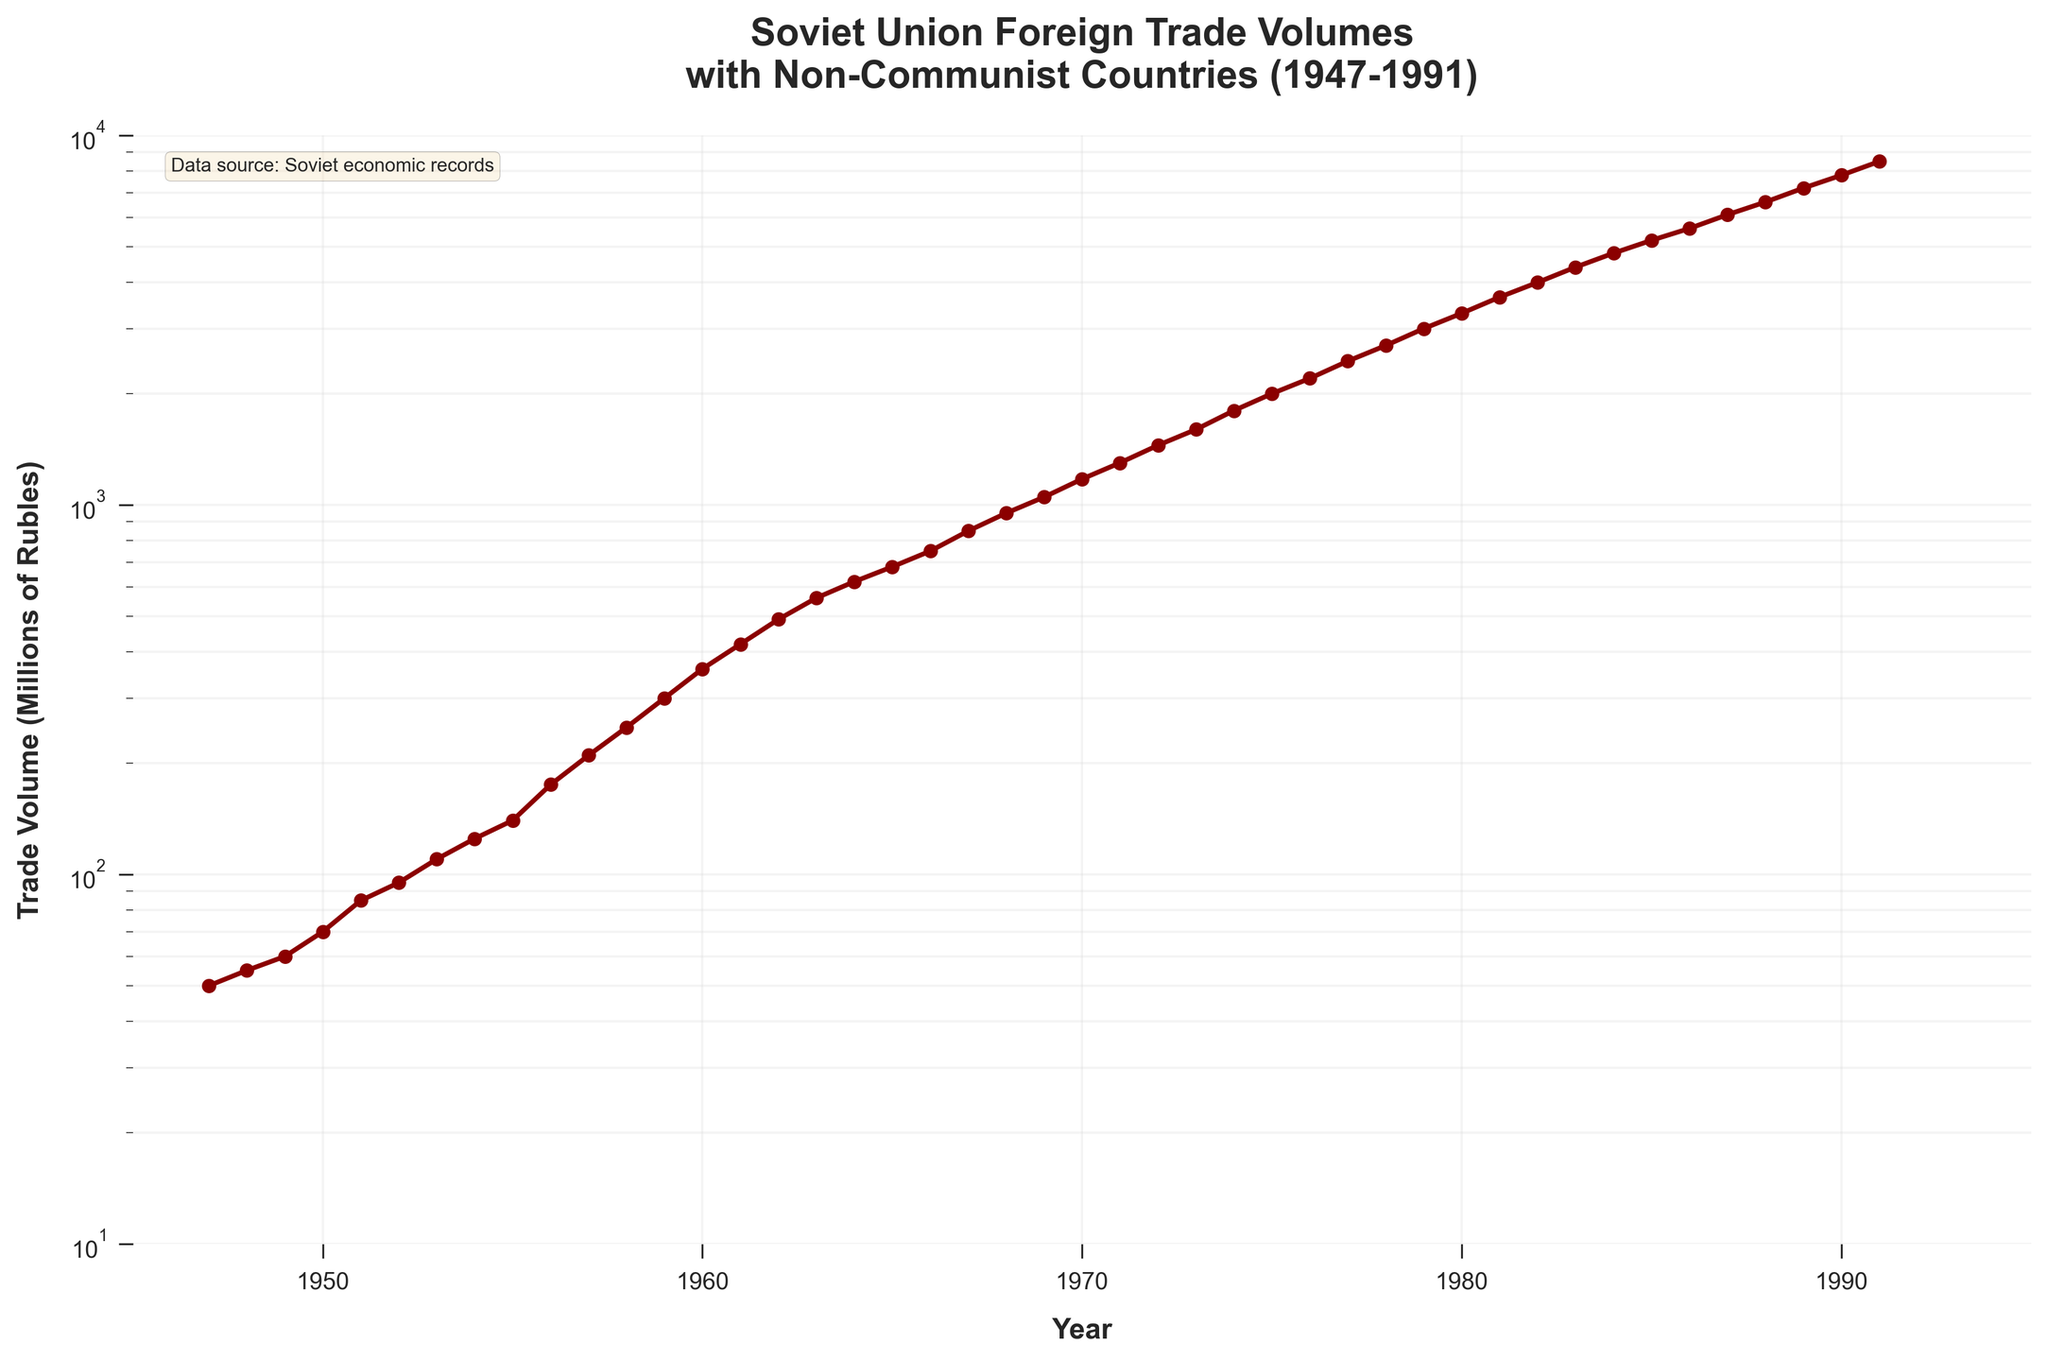What is the title of the figure? The title is located at the top of the figure and reads: "Soviet Union Foreign Trade Volumes\nwith Non-Communist Countries (1947-1991)".
Answer: Soviet Union Foreign Trade Volumes with Non-Communist Countries (1947-1991) What does the y-axis represent? The y-axis label is "Trade Volume (Millions of Rubles)", indicating the foreign trade volumes measured in millions of rubles.
Answer: Trade Volume (Millions of Rubles) What scale is used on the y-axis? The y-axis is set to a logarithmic scale as indicated by the use of "log" scaling in the plot.
Answer: Logarithmic What year had the highest trade volume? To identify the year with the highest trade volume, look for the last data point on the graph at 1991, which has the highest value on the log scale.
Answer: 1991 Between which years did the trade volume first exceed 1000 million rubles? Find the first data point that crosses the 1000 million ruble mark; this occurs just before 1970.
Answer: 1969 and 1970 How does the trade volume in 1980 compare to that in 1950? Locate the trade volumes for both specified years on the y-axis and compare; 1980 shows a trade volume significantly higher than that in 1950.
Answer: 1980 is significantly higher than 1950 What was the approximate trade volume in 1960? Find the year 1960 on the x-axis and trace up to the corresponding value on the y-axis; it reads around 360 million rubles.
Answer: 360 million rubles How many years are displayed in the plot? Subtract the starting year from the ending year and include both endpoints: 1991 - 1947 + 1 = 45 years.
Answer: 45 years What is the trend of Soviet Union's foreign trade volume from 1947 to 1991? The plot shows a continuous upward trend in the foreign trade volume over the years, indicating growth.
Answer: Upward trend What was the percentage increase in trade volume from 1947 to 1967? To find the percentage increase, calculate the difference in volumes, divide by the initial value, and multiply by 100: ((850-50)/50)*100 = 1600%.
Answer: 1600% 